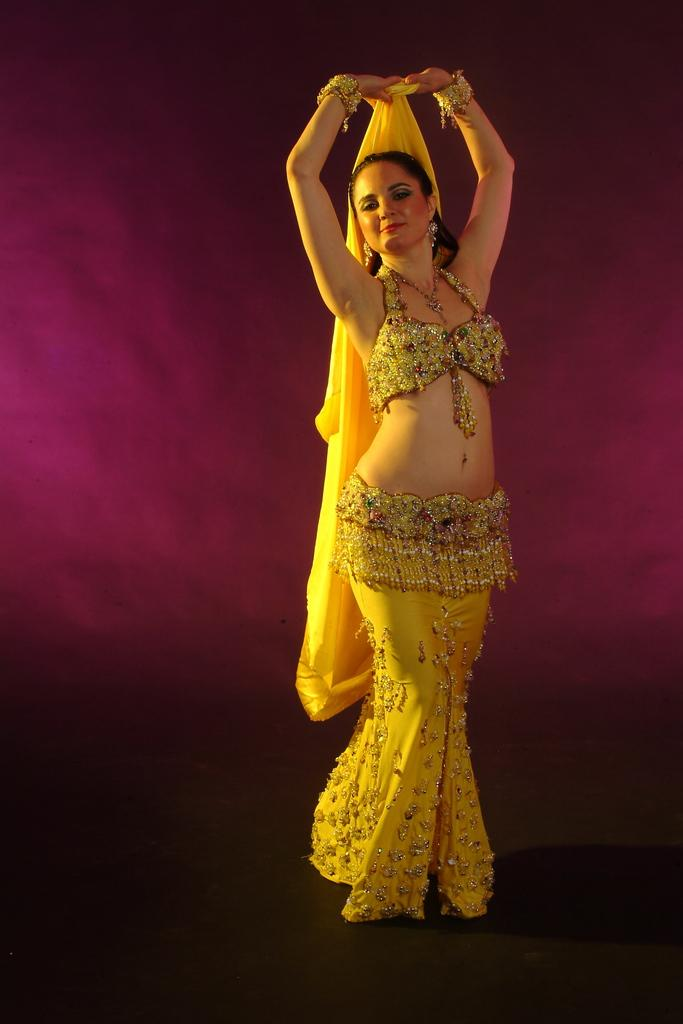Who is the main subject in the foreground of the image? There is a woman in the foreground of the image. What is the woman wearing in the image? The woman is wearing a yellow dress. Where is the woman standing in the image? The woman is standing on the floor. Can you describe the background of the image? The background of the image is colorful. What topic is the woman discussing with the beginner in the image? There is no indication of a discussion or a beginner present in the image; it only features a woman standing in a colorful background. 